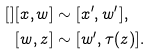Convert formula to latex. <formula><loc_0><loc_0><loc_500><loc_500>[ ] [ x , w ] & \sim [ x ^ { \prime } , w ^ { \prime } ] , \\ [ w , z ] & \sim [ w ^ { \prime } , \tau ( z ) ] . \\</formula> 